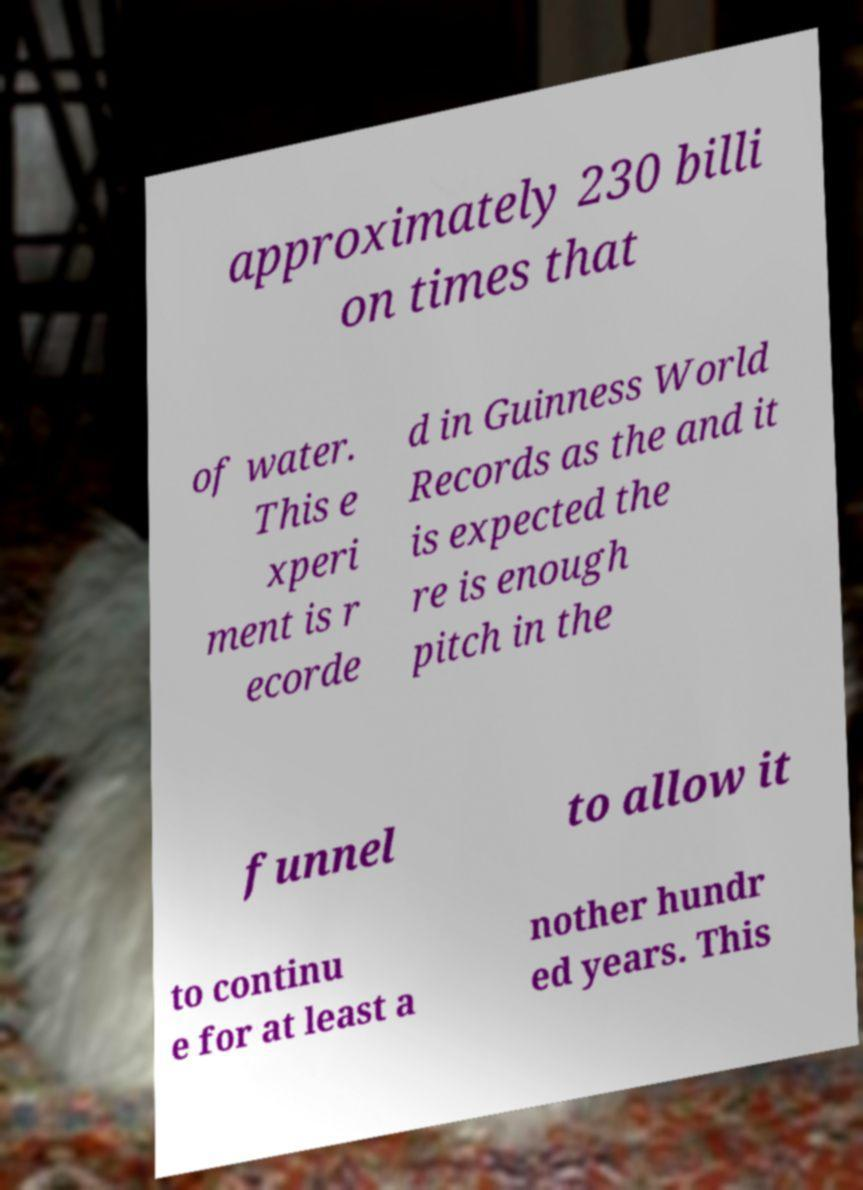There's text embedded in this image that I need extracted. Can you transcribe it verbatim? approximately 230 billi on times that of water. This e xperi ment is r ecorde d in Guinness World Records as the and it is expected the re is enough pitch in the funnel to allow it to continu e for at least a nother hundr ed years. This 